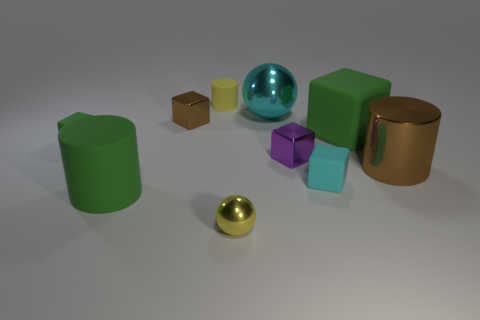There is a big metal thing that is left of the large brown metal object; is its color the same as the big rubber thing to the right of the small yellow matte cylinder?
Offer a terse response. No. Are there any large cyan cylinders made of the same material as the small brown thing?
Ensure brevity in your answer.  No. How many gray objects are small rubber cylinders or shiny cylinders?
Make the answer very short. 0. Is the number of matte things to the right of the tiny purple metallic thing greater than the number of big cubes?
Your answer should be compact. Yes. Is the purple thing the same size as the yellow ball?
Your answer should be very brief. Yes. What is the color of the other big thing that is the same material as the large cyan object?
Offer a very short reply. Brown. The tiny object that is the same color as the big matte block is what shape?
Keep it short and to the point. Cube. Is the number of tiny metallic things that are to the left of the small purple metallic cube the same as the number of small yellow matte cylinders right of the small cyan matte object?
Your response must be concise. No. What shape is the cyan thing behind the large matte block that is right of the tiny purple cube?
Your response must be concise. Sphere. There is a small purple thing that is the same shape as the tiny brown thing; what material is it?
Provide a short and direct response. Metal. 